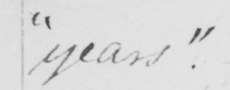Can you tell me what this handwritten text says? years . 